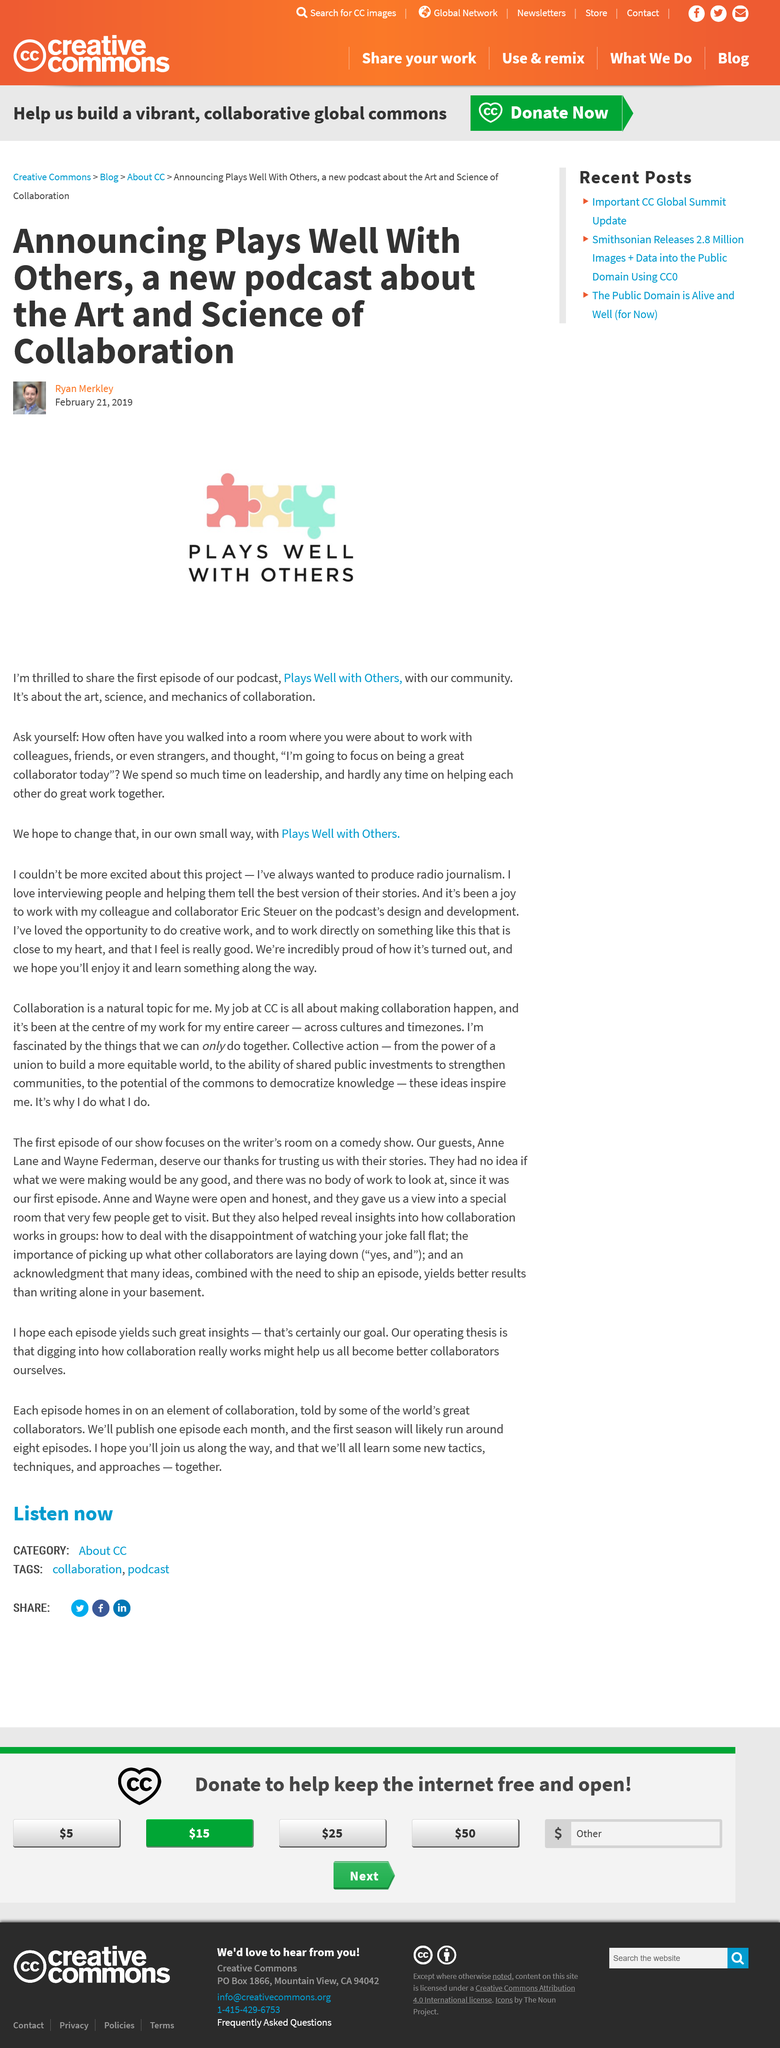Give some essential details in this illustration. The author suggests that we should collaborate with colleagues, friends, and even strangers to achieve our goals. The author criticizes the fact that we spend too much time on leadership and not enough on helping each other do great work together. The podcast focuses on the art, science, and mechanics of collaboration. 